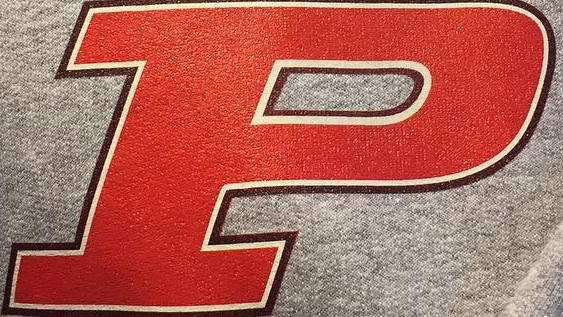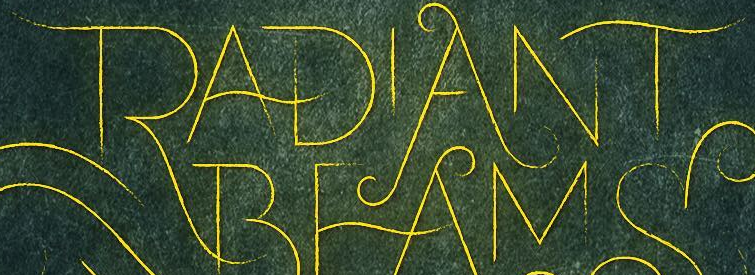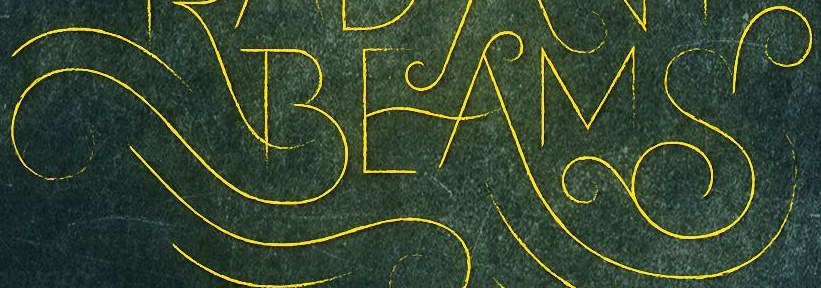Identify the words shown in these images in order, separated by a semicolon. P; RADIANT; BEAMS 